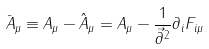<formula> <loc_0><loc_0><loc_500><loc_500>\bar { A } _ { \mu } \equiv A _ { \mu } - \hat { A } _ { \mu } = A _ { \mu } - \frac { 1 } { \vec { \partial } ^ { 2 } } \partial _ { i } F _ { i \mu }</formula> 